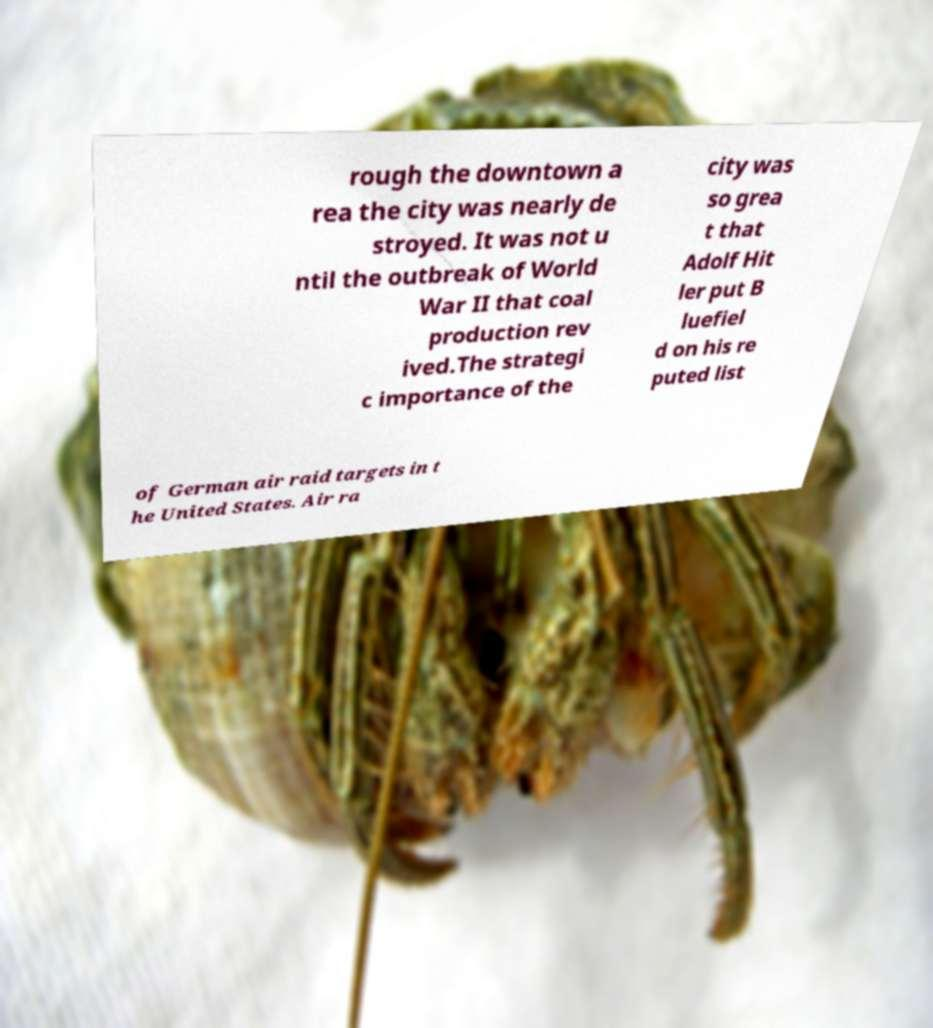There's text embedded in this image that I need extracted. Can you transcribe it verbatim? rough the downtown a rea the city was nearly de stroyed. It was not u ntil the outbreak of World War II that coal production rev ived.The strategi c importance of the city was so grea t that Adolf Hit ler put B luefiel d on his re puted list of German air raid targets in t he United States. Air ra 